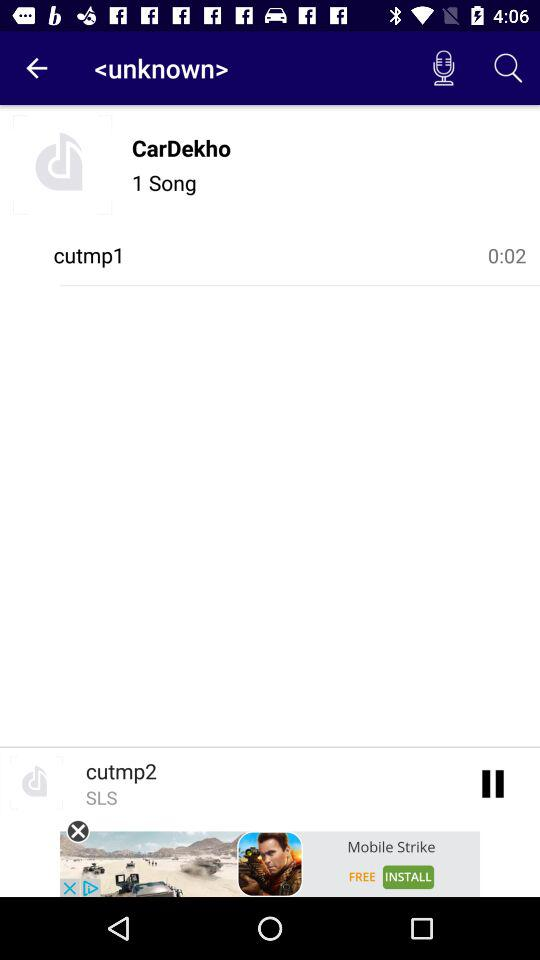What is the duration of song? The duration is 0:02. 